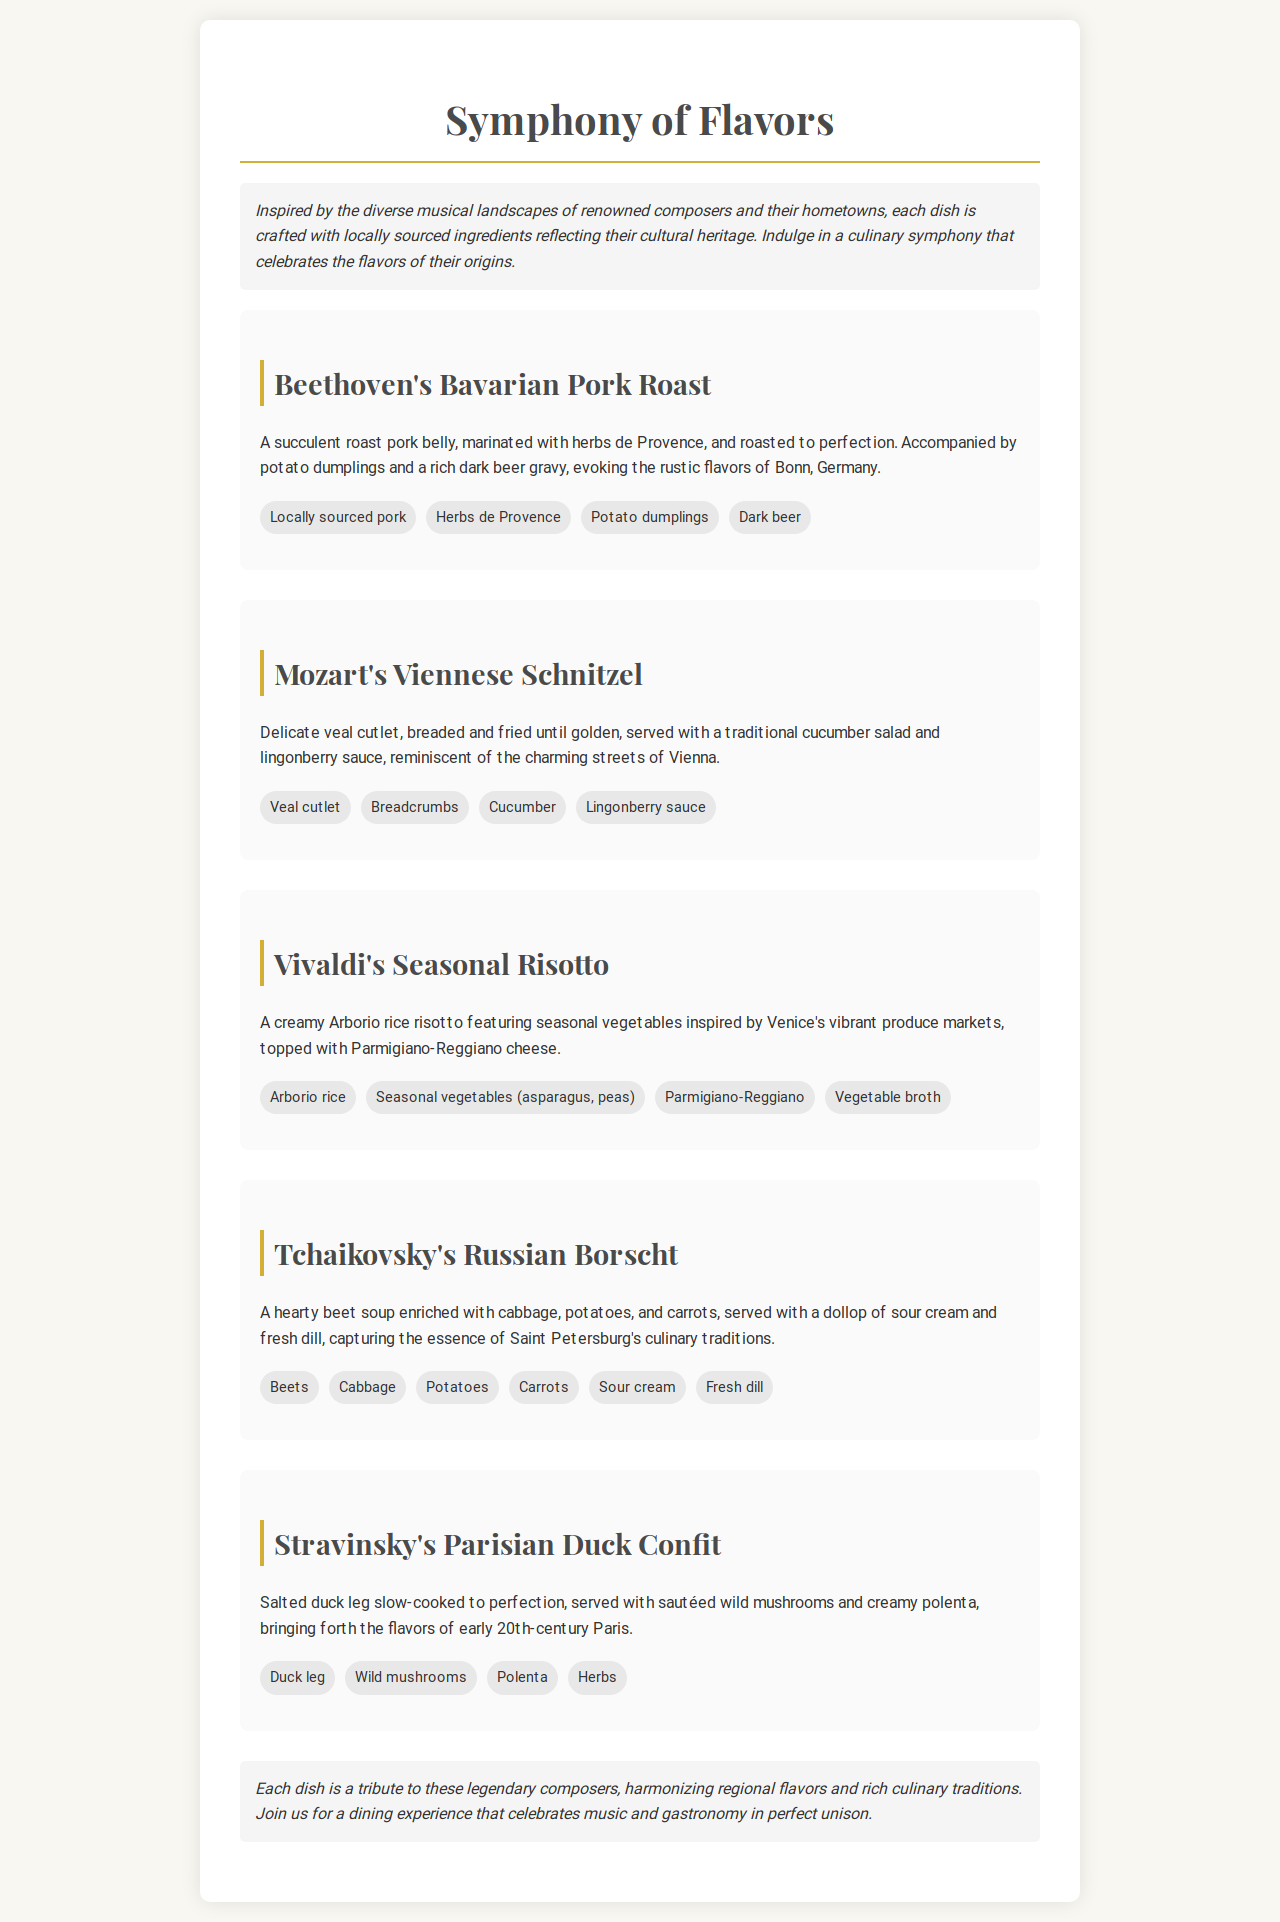what is the name of the dish inspired by Beethoven? The name of the dish inspired by Beethoven is "Beethoven's Bavarian Pork Roast."
Answer: Beethoven's Bavarian Pork Roast which vegetable is highlighted in Vivaldi's dish? Vivaldi's Seasonal Risotto features seasonal vegetables, such as asparagus and peas.
Answer: asparagus, peas how is Tchaikovsky's Russian Borscht garnished? Tchaikovsky's Russian Borscht is served with a dollop of sour cream and fresh dill.
Answer: sour cream, fresh dill what type of meat is used in Mozart's dish? Mozart's Viennese Schnitzel is made from veal cutlet.
Answer: veal cutlet which region's culinary traditions does Stravinsky's dish evoke? Stravinsky's Parisian Duck Confit brings forth the flavors of early 20th-century Paris.
Answer: early 20th-century Paris what main ingredient is used in Stravinsky's dish? The main ingredient in Stravinsky's Parisian Duck Confit is duck leg.
Answer: duck leg how many dishes are listed in the menu? There are six dishes listed in the menu.
Answer: six what common theme do the dishes celebrate? The dishes celebrate the flavors of composers' hometowns and their cultural heritage.
Answer: flavors of composers' hometowns 